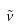Convert formula to latex. <formula><loc_0><loc_0><loc_500><loc_500>\tilde { \nu }</formula> 